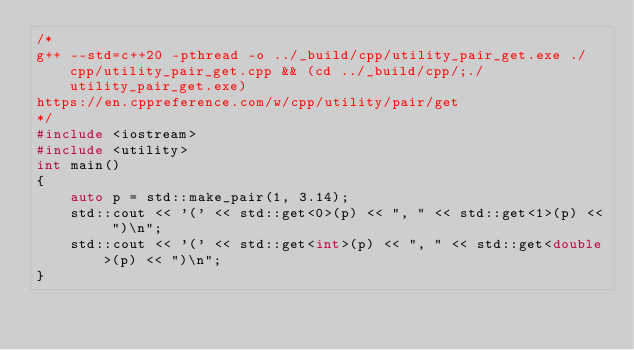<code> <loc_0><loc_0><loc_500><loc_500><_C++_>/*
g++ --std=c++20 -pthread -o ../_build/cpp/utility_pair_get.exe ./cpp/utility_pair_get.cpp && (cd ../_build/cpp/;./utility_pair_get.exe)
https://en.cppreference.com/w/cpp/utility/pair/get
*/
#include <iostream>
#include <utility>
int main()
{
    auto p = std::make_pair(1, 3.14);
    std::cout << '(' << std::get<0>(p) << ", " << std::get<1>(p) << ")\n";
    std::cout << '(' << std::get<int>(p) << ", " << std::get<double>(p) << ")\n";
}

</code> 